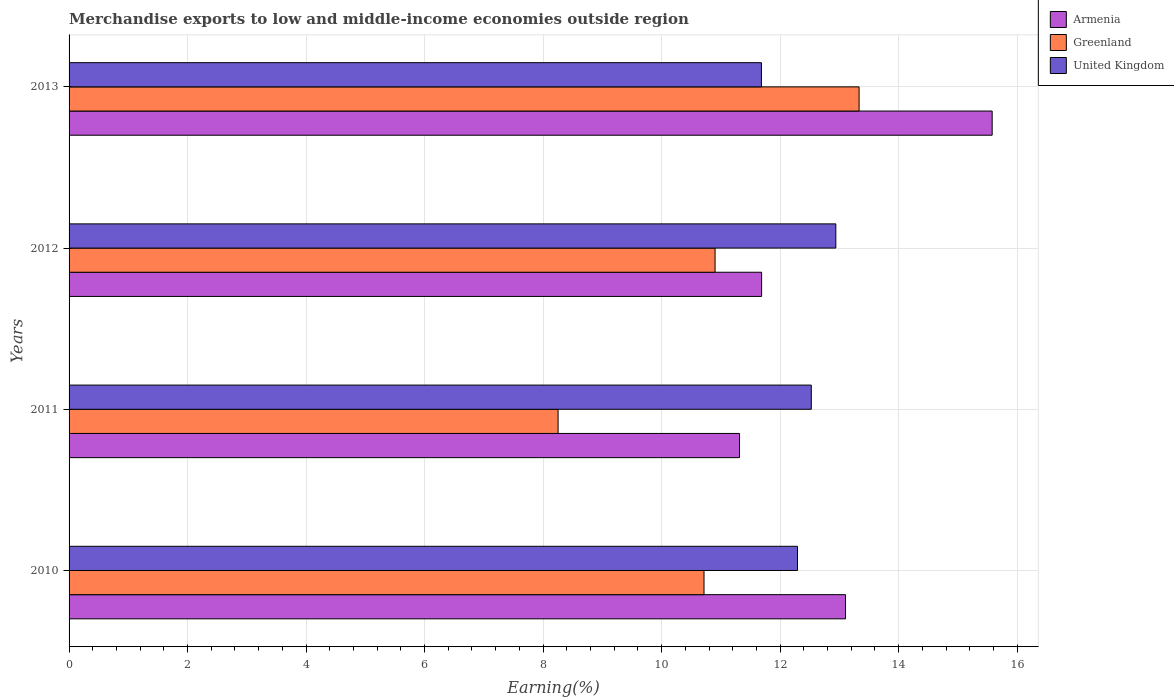How many different coloured bars are there?
Provide a succinct answer. 3. How many bars are there on the 1st tick from the top?
Provide a succinct answer. 3. How many bars are there on the 1st tick from the bottom?
Offer a very short reply. 3. What is the label of the 4th group of bars from the top?
Give a very brief answer. 2010. What is the percentage of amount earned from merchandise exports in Armenia in 2012?
Offer a very short reply. 11.69. Across all years, what is the maximum percentage of amount earned from merchandise exports in United Kingdom?
Offer a terse response. 12.94. Across all years, what is the minimum percentage of amount earned from merchandise exports in Greenland?
Provide a short and direct response. 8.25. What is the total percentage of amount earned from merchandise exports in Greenland in the graph?
Make the answer very short. 43.21. What is the difference between the percentage of amount earned from merchandise exports in Armenia in 2012 and that in 2013?
Make the answer very short. -3.89. What is the difference between the percentage of amount earned from merchandise exports in Greenland in 2010 and the percentage of amount earned from merchandise exports in United Kingdom in 2013?
Provide a succinct answer. -0.97. What is the average percentage of amount earned from merchandise exports in United Kingdom per year?
Give a very brief answer. 12.36. In the year 2010, what is the difference between the percentage of amount earned from merchandise exports in United Kingdom and percentage of amount earned from merchandise exports in Greenland?
Your response must be concise. 1.58. What is the ratio of the percentage of amount earned from merchandise exports in United Kingdom in 2012 to that in 2013?
Provide a succinct answer. 1.11. Is the difference between the percentage of amount earned from merchandise exports in United Kingdom in 2010 and 2012 greater than the difference between the percentage of amount earned from merchandise exports in Greenland in 2010 and 2012?
Keep it short and to the point. No. What is the difference between the highest and the second highest percentage of amount earned from merchandise exports in United Kingdom?
Your answer should be very brief. 0.41. What is the difference between the highest and the lowest percentage of amount earned from merchandise exports in Greenland?
Your answer should be very brief. 5.08. Is the sum of the percentage of amount earned from merchandise exports in Greenland in 2010 and 2011 greater than the maximum percentage of amount earned from merchandise exports in United Kingdom across all years?
Give a very brief answer. Yes. What does the 2nd bar from the top in 2010 represents?
Give a very brief answer. Greenland. What does the 1st bar from the bottom in 2010 represents?
Your answer should be very brief. Armenia. Is it the case that in every year, the sum of the percentage of amount earned from merchandise exports in Armenia and percentage of amount earned from merchandise exports in Greenland is greater than the percentage of amount earned from merchandise exports in United Kingdom?
Offer a very short reply. Yes. How many years are there in the graph?
Make the answer very short. 4. What is the difference between two consecutive major ticks on the X-axis?
Ensure brevity in your answer.  2. Are the values on the major ticks of X-axis written in scientific E-notation?
Your response must be concise. No. Where does the legend appear in the graph?
Offer a very short reply. Top right. How are the legend labels stacked?
Keep it short and to the point. Vertical. What is the title of the graph?
Provide a succinct answer. Merchandise exports to low and middle-income economies outside region. What is the label or title of the X-axis?
Give a very brief answer. Earning(%). What is the Earning(%) in Armenia in 2010?
Ensure brevity in your answer.  13.1. What is the Earning(%) in Greenland in 2010?
Your answer should be very brief. 10.72. What is the Earning(%) of United Kingdom in 2010?
Provide a succinct answer. 12.29. What is the Earning(%) of Armenia in 2011?
Provide a short and direct response. 11.32. What is the Earning(%) in Greenland in 2011?
Provide a short and direct response. 8.25. What is the Earning(%) in United Kingdom in 2011?
Your response must be concise. 12.53. What is the Earning(%) of Armenia in 2012?
Ensure brevity in your answer.  11.69. What is the Earning(%) of Greenland in 2012?
Your answer should be compact. 10.9. What is the Earning(%) in United Kingdom in 2012?
Provide a succinct answer. 12.94. What is the Earning(%) in Armenia in 2013?
Your answer should be very brief. 15.58. What is the Earning(%) of Greenland in 2013?
Offer a terse response. 13.33. What is the Earning(%) of United Kingdom in 2013?
Your answer should be compact. 11.68. Across all years, what is the maximum Earning(%) of Armenia?
Give a very brief answer. 15.58. Across all years, what is the maximum Earning(%) in Greenland?
Offer a terse response. 13.33. Across all years, what is the maximum Earning(%) in United Kingdom?
Provide a short and direct response. 12.94. Across all years, what is the minimum Earning(%) in Armenia?
Make the answer very short. 11.32. Across all years, what is the minimum Earning(%) of Greenland?
Your response must be concise. 8.25. Across all years, what is the minimum Earning(%) in United Kingdom?
Provide a succinct answer. 11.68. What is the total Earning(%) of Armenia in the graph?
Your answer should be very brief. 51.69. What is the total Earning(%) of Greenland in the graph?
Offer a terse response. 43.2. What is the total Earning(%) of United Kingdom in the graph?
Ensure brevity in your answer.  49.45. What is the difference between the Earning(%) in Armenia in 2010 and that in 2011?
Offer a very short reply. 1.79. What is the difference between the Earning(%) of Greenland in 2010 and that in 2011?
Provide a short and direct response. 2.46. What is the difference between the Earning(%) in United Kingdom in 2010 and that in 2011?
Your answer should be very brief. -0.23. What is the difference between the Earning(%) of Armenia in 2010 and that in 2012?
Your answer should be very brief. 1.42. What is the difference between the Earning(%) in Greenland in 2010 and that in 2012?
Offer a very short reply. -0.19. What is the difference between the Earning(%) of United Kingdom in 2010 and that in 2012?
Your answer should be very brief. -0.65. What is the difference between the Earning(%) in Armenia in 2010 and that in 2013?
Offer a very short reply. -2.48. What is the difference between the Earning(%) of Greenland in 2010 and that in 2013?
Make the answer very short. -2.62. What is the difference between the Earning(%) in United Kingdom in 2010 and that in 2013?
Provide a succinct answer. 0.61. What is the difference between the Earning(%) of Armenia in 2011 and that in 2012?
Provide a succinct answer. -0.37. What is the difference between the Earning(%) of Greenland in 2011 and that in 2012?
Provide a short and direct response. -2.65. What is the difference between the Earning(%) of United Kingdom in 2011 and that in 2012?
Keep it short and to the point. -0.41. What is the difference between the Earning(%) of Armenia in 2011 and that in 2013?
Your answer should be very brief. -4.26. What is the difference between the Earning(%) of Greenland in 2011 and that in 2013?
Make the answer very short. -5.08. What is the difference between the Earning(%) of United Kingdom in 2011 and that in 2013?
Provide a short and direct response. 0.84. What is the difference between the Earning(%) in Armenia in 2012 and that in 2013?
Provide a succinct answer. -3.89. What is the difference between the Earning(%) of Greenland in 2012 and that in 2013?
Give a very brief answer. -2.43. What is the difference between the Earning(%) in United Kingdom in 2012 and that in 2013?
Offer a very short reply. 1.26. What is the difference between the Earning(%) of Armenia in 2010 and the Earning(%) of Greenland in 2011?
Keep it short and to the point. 4.85. What is the difference between the Earning(%) in Armenia in 2010 and the Earning(%) in United Kingdom in 2011?
Give a very brief answer. 0.58. What is the difference between the Earning(%) of Greenland in 2010 and the Earning(%) of United Kingdom in 2011?
Offer a terse response. -1.81. What is the difference between the Earning(%) of Armenia in 2010 and the Earning(%) of Greenland in 2012?
Offer a terse response. 2.2. What is the difference between the Earning(%) of Armenia in 2010 and the Earning(%) of United Kingdom in 2012?
Offer a terse response. 0.16. What is the difference between the Earning(%) of Greenland in 2010 and the Earning(%) of United Kingdom in 2012?
Ensure brevity in your answer.  -2.22. What is the difference between the Earning(%) of Armenia in 2010 and the Earning(%) of Greenland in 2013?
Ensure brevity in your answer.  -0.23. What is the difference between the Earning(%) in Armenia in 2010 and the Earning(%) in United Kingdom in 2013?
Your response must be concise. 1.42. What is the difference between the Earning(%) of Greenland in 2010 and the Earning(%) of United Kingdom in 2013?
Provide a short and direct response. -0.97. What is the difference between the Earning(%) in Armenia in 2011 and the Earning(%) in Greenland in 2012?
Provide a short and direct response. 0.41. What is the difference between the Earning(%) in Armenia in 2011 and the Earning(%) in United Kingdom in 2012?
Offer a terse response. -1.63. What is the difference between the Earning(%) of Greenland in 2011 and the Earning(%) of United Kingdom in 2012?
Your answer should be compact. -4.69. What is the difference between the Earning(%) in Armenia in 2011 and the Earning(%) in Greenland in 2013?
Keep it short and to the point. -2.02. What is the difference between the Earning(%) of Armenia in 2011 and the Earning(%) of United Kingdom in 2013?
Keep it short and to the point. -0.37. What is the difference between the Earning(%) in Greenland in 2011 and the Earning(%) in United Kingdom in 2013?
Your answer should be very brief. -3.43. What is the difference between the Earning(%) in Armenia in 2012 and the Earning(%) in Greenland in 2013?
Provide a succinct answer. -1.65. What is the difference between the Earning(%) of Armenia in 2012 and the Earning(%) of United Kingdom in 2013?
Provide a succinct answer. 0. What is the difference between the Earning(%) of Greenland in 2012 and the Earning(%) of United Kingdom in 2013?
Your answer should be compact. -0.78. What is the average Earning(%) in Armenia per year?
Offer a terse response. 12.92. What is the average Earning(%) of Greenland per year?
Offer a very short reply. 10.8. What is the average Earning(%) of United Kingdom per year?
Your response must be concise. 12.36. In the year 2010, what is the difference between the Earning(%) in Armenia and Earning(%) in Greenland?
Give a very brief answer. 2.39. In the year 2010, what is the difference between the Earning(%) of Armenia and Earning(%) of United Kingdom?
Make the answer very short. 0.81. In the year 2010, what is the difference between the Earning(%) of Greenland and Earning(%) of United Kingdom?
Your answer should be compact. -1.58. In the year 2011, what is the difference between the Earning(%) in Armenia and Earning(%) in Greenland?
Offer a very short reply. 3.06. In the year 2011, what is the difference between the Earning(%) of Armenia and Earning(%) of United Kingdom?
Your answer should be compact. -1.21. In the year 2011, what is the difference between the Earning(%) in Greenland and Earning(%) in United Kingdom?
Provide a succinct answer. -4.27. In the year 2012, what is the difference between the Earning(%) in Armenia and Earning(%) in Greenland?
Ensure brevity in your answer.  0.79. In the year 2012, what is the difference between the Earning(%) in Armenia and Earning(%) in United Kingdom?
Provide a succinct answer. -1.25. In the year 2012, what is the difference between the Earning(%) of Greenland and Earning(%) of United Kingdom?
Your answer should be very brief. -2.04. In the year 2013, what is the difference between the Earning(%) in Armenia and Earning(%) in Greenland?
Provide a succinct answer. 2.25. In the year 2013, what is the difference between the Earning(%) in Armenia and Earning(%) in United Kingdom?
Give a very brief answer. 3.89. In the year 2013, what is the difference between the Earning(%) of Greenland and Earning(%) of United Kingdom?
Your answer should be very brief. 1.65. What is the ratio of the Earning(%) in Armenia in 2010 to that in 2011?
Give a very brief answer. 1.16. What is the ratio of the Earning(%) in Greenland in 2010 to that in 2011?
Give a very brief answer. 1.3. What is the ratio of the Earning(%) of United Kingdom in 2010 to that in 2011?
Your answer should be compact. 0.98. What is the ratio of the Earning(%) of Armenia in 2010 to that in 2012?
Your response must be concise. 1.12. What is the ratio of the Earning(%) of Greenland in 2010 to that in 2012?
Give a very brief answer. 0.98. What is the ratio of the Earning(%) of United Kingdom in 2010 to that in 2012?
Give a very brief answer. 0.95. What is the ratio of the Earning(%) of Armenia in 2010 to that in 2013?
Ensure brevity in your answer.  0.84. What is the ratio of the Earning(%) in Greenland in 2010 to that in 2013?
Your answer should be compact. 0.8. What is the ratio of the Earning(%) in United Kingdom in 2010 to that in 2013?
Offer a terse response. 1.05. What is the ratio of the Earning(%) of Armenia in 2011 to that in 2012?
Provide a short and direct response. 0.97. What is the ratio of the Earning(%) in Greenland in 2011 to that in 2012?
Offer a terse response. 0.76. What is the ratio of the Earning(%) in Armenia in 2011 to that in 2013?
Provide a short and direct response. 0.73. What is the ratio of the Earning(%) of Greenland in 2011 to that in 2013?
Keep it short and to the point. 0.62. What is the ratio of the Earning(%) of United Kingdom in 2011 to that in 2013?
Offer a very short reply. 1.07. What is the ratio of the Earning(%) in Armenia in 2012 to that in 2013?
Keep it short and to the point. 0.75. What is the ratio of the Earning(%) of Greenland in 2012 to that in 2013?
Your response must be concise. 0.82. What is the ratio of the Earning(%) in United Kingdom in 2012 to that in 2013?
Your answer should be very brief. 1.11. What is the difference between the highest and the second highest Earning(%) of Armenia?
Provide a short and direct response. 2.48. What is the difference between the highest and the second highest Earning(%) in Greenland?
Offer a terse response. 2.43. What is the difference between the highest and the second highest Earning(%) in United Kingdom?
Provide a succinct answer. 0.41. What is the difference between the highest and the lowest Earning(%) in Armenia?
Your response must be concise. 4.26. What is the difference between the highest and the lowest Earning(%) in Greenland?
Your response must be concise. 5.08. What is the difference between the highest and the lowest Earning(%) of United Kingdom?
Keep it short and to the point. 1.26. 